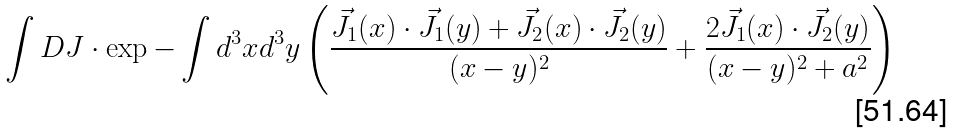<formula> <loc_0><loc_0><loc_500><loc_500>\int D J \cdot \exp - \int d ^ { 3 } x d ^ { 3 } y \left ( \frac { \vec { J } _ { 1 } ( x ) \cdot \vec { J } _ { 1 } ( y ) + \vec { J } _ { 2 } ( x ) \cdot \vec { J } _ { 2 } ( y ) } { ( x - y ) ^ { 2 } } + \frac { 2 \vec { J } _ { 1 } ( x ) \cdot \vec { J } _ { 2 } ( y ) } { ( x - y ) ^ { 2 } + a ^ { 2 } } \right )</formula> 